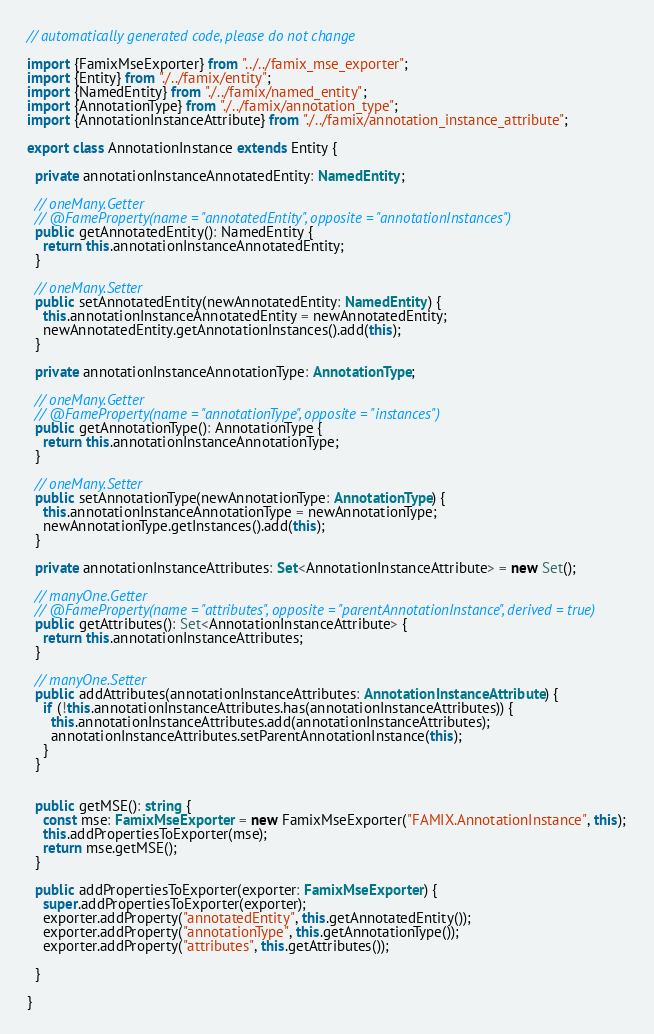Convert code to text. <code><loc_0><loc_0><loc_500><loc_500><_TypeScript_>// automatically generated code, please do not change

import {FamixMseExporter} from "../../famix_mse_exporter";
import {Entity} from "./../famix/entity";
import {NamedEntity} from "./../famix/named_entity";
import {AnnotationType} from "./../famix/annotation_type";
import {AnnotationInstanceAttribute} from "./../famix/annotation_instance_attribute";

export class AnnotationInstance extends Entity {

  private annotationInstanceAnnotatedEntity: NamedEntity;

  // oneMany.Getter
  // @FameProperty(name = "annotatedEntity", opposite = "annotationInstances")
  public getAnnotatedEntity(): NamedEntity {
    return this.annotationInstanceAnnotatedEntity;
  }

  // oneMany.Setter
  public setAnnotatedEntity(newAnnotatedEntity: NamedEntity) {
    this.annotationInstanceAnnotatedEntity = newAnnotatedEntity;
    newAnnotatedEntity.getAnnotationInstances().add(this);
  }

  private annotationInstanceAnnotationType: AnnotationType;

  // oneMany.Getter
  // @FameProperty(name = "annotationType", opposite = "instances")
  public getAnnotationType(): AnnotationType {
    return this.annotationInstanceAnnotationType;
  }

  // oneMany.Setter
  public setAnnotationType(newAnnotationType: AnnotationType) {
    this.annotationInstanceAnnotationType = newAnnotationType;
    newAnnotationType.getInstances().add(this);
  }

  private annotationInstanceAttributes: Set<AnnotationInstanceAttribute> = new Set();

  // manyOne.Getter
  // @FameProperty(name = "attributes", opposite = "parentAnnotationInstance", derived = true)
  public getAttributes(): Set<AnnotationInstanceAttribute> {
    return this.annotationInstanceAttributes;
  }

  // manyOne.Setter
  public addAttributes(annotationInstanceAttributes: AnnotationInstanceAttribute) {
    if (!this.annotationInstanceAttributes.has(annotationInstanceAttributes)) {
      this.annotationInstanceAttributes.add(annotationInstanceAttributes);
      annotationInstanceAttributes.setParentAnnotationInstance(this);
    }
  }


  public getMSE(): string {
    const mse: FamixMseExporter = new FamixMseExporter("FAMIX.AnnotationInstance", this);
    this.addPropertiesToExporter(mse);
    return mse.getMSE();
  }

  public addPropertiesToExporter(exporter: FamixMseExporter) {
    super.addPropertiesToExporter(exporter);
    exporter.addProperty("annotatedEntity", this.getAnnotatedEntity());
    exporter.addProperty("annotationType", this.getAnnotationType());
    exporter.addProperty("attributes", this.getAttributes());

  }

}

</code> 